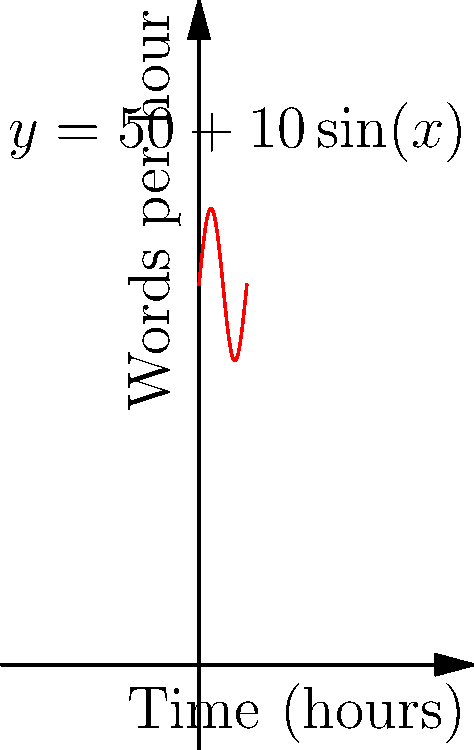As a freelance writer, your productivity varies throughout the day. The graph shows your writing speed in words per hour over a 6-hour period, represented by the function $y = 50 + 10\sin(x)$, where $x$ is in hours. Calculate the total number of words you've written during this 6-hour period. To find the total number of words written, we need to calculate the area under the curve over the 6-hour period. This can be done using integral calculus:

1) The function representing words per hour is $f(x) = 50 + 10\sin(x)$

2) We need to integrate this function from 0 to 6π (since 6 hours = 6π in radians):

   $\int_0^{6\pi} (50 + 10\sin(x)) dx$

3) Let's split this into two integrals:

   $\int_0^{6\pi} 50 dx + \int_0^{6\pi} 10\sin(x) dx$

4) Solving the first integral:
   $50x|_0^{6\pi} = 50(6\pi) - 50(0) = 300\pi$

5) Solving the second integral:
   $-10\cos(x)|_0^{6\pi} = -10(\cos(6\pi) - \cos(0)) = -10(1 - 1) = 0$

6) Adding the results:
   $300\pi + 0 = 300\pi$

7) $300\pi \approx 942.48$ words

Therefore, you've written approximately 942 words during this 6-hour period.
Answer: 942 words 